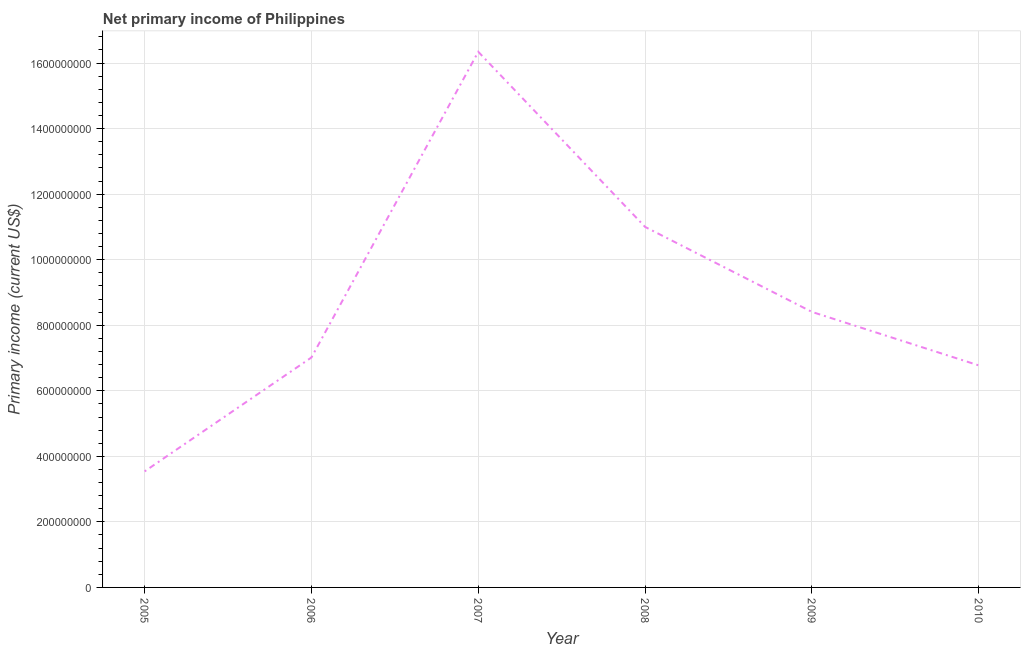What is the amount of primary income in 2005?
Keep it short and to the point. 3.54e+08. Across all years, what is the maximum amount of primary income?
Offer a terse response. 1.63e+09. Across all years, what is the minimum amount of primary income?
Your answer should be compact. 3.54e+08. In which year was the amount of primary income maximum?
Give a very brief answer. 2007. What is the sum of the amount of primary income?
Your answer should be very brief. 5.31e+09. What is the difference between the amount of primary income in 2005 and 2010?
Provide a short and direct response. -3.23e+08. What is the average amount of primary income per year?
Offer a very short reply. 8.85e+08. What is the median amount of primary income?
Make the answer very short. 7.71e+08. What is the ratio of the amount of primary income in 2005 to that in 2009?
Your response must be concise. 0.42. Is the amount of primary income in 2008 less than that in 2009?
Make the answer very short. No. What is the difference between the highest and the second highest amount of primary income?
Your answer should be compact. 5.34e+08. Is the sum of the amount of primary income in 2007 and 2010 greater than the maximum amount of primary income across all years?
Your answer should be very brief. Yes. What is the difference between the highest and the lowest amount of primary income?
Ensure brevity in your answer.  1.28e+09. In how many years, is the amount of primary income greater than the average amount of primary income taken over all years?
Keep it short and to the point. 2. Does the amount of primary income monotonically increase over the years?
Provide a succinct answer. No. Does the graph contain any zero values?
Offer a terse response. No. What is the title of the graph?
Keep it short and to the point. Net primary income of Philippines. What is the label or title of the X-axis?
Ensure brevity in your answer.  Year. What is the label or title of the Y-axis?
Give a very brief answer. Primary income (current US$). What is the Primary income (current US$) of 2005?
Ensure brevity in your answer.  3.54e+08. What is the Primary income (current US$) of 2006?
Offer a very short reply. 7.02e+08. What is the Primary income (current US$) of 2007?
Ensure brevity in your answer.  1.63e+09. What is the Primary income (current US$) of 2008?
Ensure brevity in your answer.  1.10e+09. What is the Primary income (current US$) in 2009?
Offer a terse response. 8.41e+08. What is the Primary income (current US$) in 2010?
Your response must be concise. 6.77e+08. What is the difference between the Primary income (current US$) in 2005 and 2006?
Your answer should be compact. -3.48e+08. What is the difference between the Primary income (current US$) in 2005 and 2007?
Your response must be concise. -1.28e+09. What is the difference between the Primary income (current US$) in 2005 and 2008?
Provide a short and direct response. -7.46e+08. What is the difference between the Primary income (current US$) in 2005 and 2009?
Provide a succinct answer. -4.87e+08. What is the difference between the Primary income (current US$) in 2005 and 2010?
Make the answer very short. -3.23e+08. What is the difference between the Primary income (current US$) in 2006 and 2007?
Give a very brief answer. -9.33e+08. What is the difference between the Primary income (current US$) in 2006 and 2008?
Make the answer very short. -3.98e+08. What is the difference between the Primary income (current US$) in 2006 and 2009?
Make the answer very short. -1.39e+08. What is the difference between the Primary income (current US$) in 2006 and 2010?
Your answer should be very brief. 2.42e+07. What is the difference between the Primary income (current US$) in 2007 and 2008?
Your response must be concise. 5.34e+08. What is the difference between the Primary income (current US$) in 2007 and 2009?
Make the answer very short. 7.94e+08. What is the difference between the Primary income (current US$) in 2007 and 2010?
Your response must be concise. 9.57e+08. What is the difference between the Primary income (current US$) in 2008 and 2009?
Provide a short and direct response. 2.59e+08. What is the difference between the Primary income (current US$) in 2008 and 2010?
Your response must be concise. 4.23e+08. What is the difference between the Primary income (current US$) in 2009 and 2010?
Give a very brief answer. 1.63e+08. What is the ratio of the Primary income (current US$) in 2005 to that in 2006?
Offer a very short reply. 0.51. What is the ratio of the Primary income (current US$) in 2005 to that in 2007?
Your answer should be very brief. 0.22. What is the ratio of the Primary income (current US$) in 2005 to that in 2008?
Your response must be concise. 0.32. What is the ratio of the Primary income (current US$) in 2005 to that in 2009?
Ensure brevity in your answer.  0.42. What is the ratio of the Primary income (current US$) in 2005 to that in 2010?
Offer a very short reply. 0.52. What is the ratio of the Primary income (current US$) in 2006 to that in 2007?
Provide a succinct answer. 0.43. What is the ratio of the Primary income (current US$) in 2006 to that in 2008?
Your response must be concise. 0.64. What is the ratio of the Primary income (current US$) in 2006 to that in 2009?
Your response must be concise. 0.83. What is the ratio of the Primary income (current US$) in 2006 to that in 2010?
Give a very brief answer. 1.04. What is the ratio of the Primary income (current US$) in 2007 to that in 2008?
Provide a short and direct response. 1.49. What is the ratio of the Primary income (current US$) in 2007 to that in 2009?
Offer a terse response. 1.94. What is the ratio of the Primary income (current US$) in 2007 to that in 2010?
Keep it short and to the point. 2.41. What is the ratio of the Primary income (current US$) in 2008 to that in 2009?
Your answer should be very brief. 1.31. What is the ratio of the Primary income (current US$) in 2008 to that in 2010?
Offer a terse response. 1.62. What is the ratio of the Primary income (current US$) in 2009 to that in 2010?
Your answer should be compact. 1.24. 